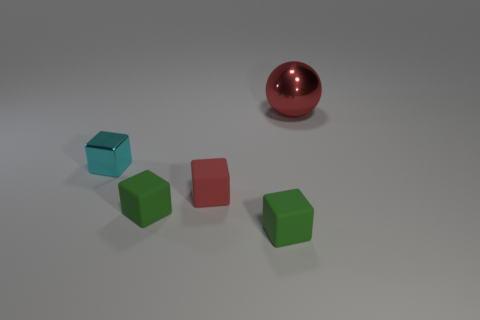Add 5 red blocks. How many objects exist? 10 Subtract all balls. How many objects are left? 4 Subtract all small rubber objects. Subtract all big metallic spheres. How many objects are left? 1 Add 3 rubber cubes. How many rubber cubes are left? 6 Add 2 gray objects. How many gray objects exist? 2 Subtract 1 green cubes. How many objects are left? 4 